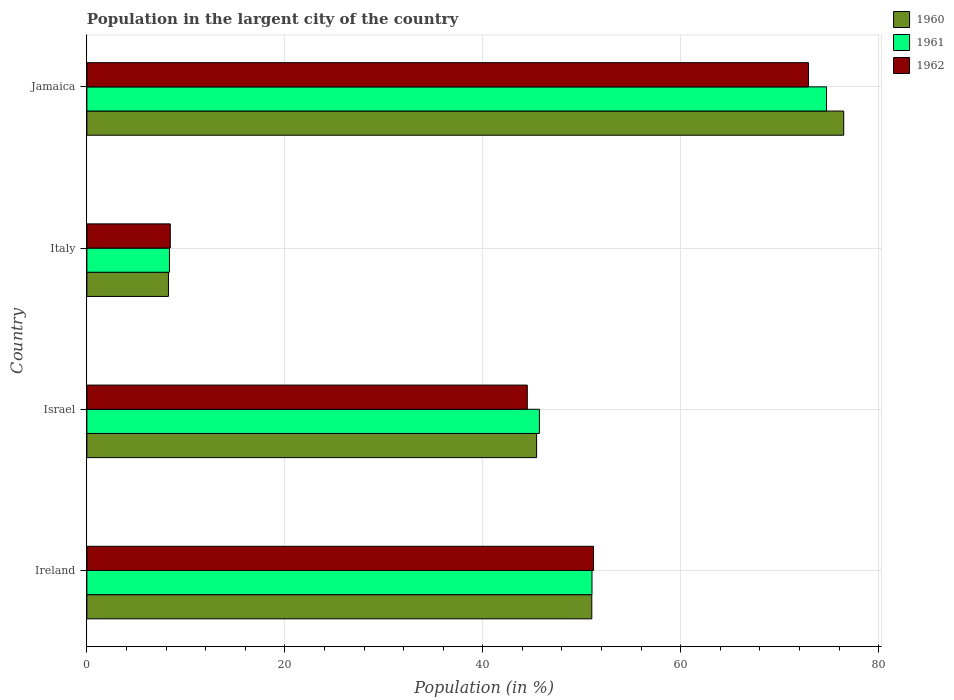Are the number of bars per tick equal to the number of legend labels?
Keep it short and to the point. Yes. Are the number of bars on each tick of the Y-axis equal?
Offer a terse response. Yes. How many bars are there on the 3rd tick from the top?
Your response must be concise. 3. What is the label of the 2nd group of bars from the top?
Provide a succinct answer. Italy. What is the percentage of population in the largent city in 1962 in Italy?
Ensure brevity in your answer.  8.42. Across all countries, what is the maximum percentage of population in the largent city in 1962?
Provide a short and direct response. 72.91. Across all countries, what is the minimum percentage of population in the largent city in 1961?
Your answer should be very brief. 8.34. In which country was the percentage of population in the largent city in 1961 maximum?
Your answer should be compact. Jamaica. In which country was the percentage of population in the largent city in 1961 minimum?
Provide a succinct answer. Italy. What is the total percentage of population in the largent city in 1962 in the graph?
Your answer should be compact. 177.01. What is the difference between the percentage of population in the largent city in 1961 in Israel and that in Jamaica?
Ensure brevity in your answer.  -29.01. What is the difference between the percentage of population in the largent city in 1961 in Ireland and the percentage of population in the largent city in 1962 in Jamaica?
Your answer should be very brief. -21.88. What is the average percentage of population in the largent city in 1960 per country?
Offer a very short reply. 45.29. What is the difference between the percentage of population in the largent city in 1960 and percentage of population in the largent city in 1961 in Ireland?
Provide a succinct answer. -0.02. What is the ratio of the percentage of population in the largent city in 1960 in Ireland to that in Italy?
Offer a very short reply. 6.19. What is the difference between the highest and the second highest percentage of population in the largent city in 1960?
Provide a short and direct response. 25.45. What is the difference between the highest and the lowest percentage of population in the largent city in 1961?
Your answer should be very brief. 66.39. Is the sum of the percentage of population in the largent city in 1960 in Ireland and Jamaica greater than the maximum percentage of population in the largent city in 1961 across all countries?
Your answer should be very brief. Yes. Is it the case that in every country, the sum of the percentage of population in the largent city in 1961 and percentage of population in the largent city in 1960 is greater than the percentage of population in the largent city in 1962?
Provide a short and direct response. Yes. How many bars are there?
Give a very brief answer. 12. Are all the bars in the graph horizontal?
Ensure brevity in your answer.  Yes. Are the values on the major ticks of X-axis written in scientific E-notation?
Keep it short and to the point. No. Where does the legend appear in the graph?
Ensure brevity in your answer.  Top right. How many legend labels are there?
Provide a succinct answer. 3. What is the title of the graph?
Ensure brevity in your answer.  Population in the largent city of the country. What is the label or title of the X-axis?
Make the answer very short. Population (in %). What is the Population (in %) in 1960 in Ireland?
Offer a very short reply. 51.01. What is the Population (in %) of 1961 in Ireland?
Your answer should be compact. 51.03. What is the Population (in %) of 1962 in Ireland?
Your response must be concise. 51.19. What is the Population (in %) of 1960 in Israel?
Offer a terse response. 45.44. What is the Population (in %) of 1961 in Israel?
Offer a very short reply. 45.72. What is the Population (in %) in 1962 in Israel?
Ensure brevity in your answer.  44.5. What is the Population (in %) of 1960 in Italy?
Make the answer very short. 8.24. What is the Population (in %) in 1961 in Italy?
Your answer should be very brief. 8.34. What is the Population (in %) in 1962 in Italy?
Provide a short and direct response. 8.42. What is the Population (in %) in 1960 in Jamaica?
Offer a terse response. 76.46. What is the Population (in %) of 1961 in Jamaica?
Provide a short and direct response. 74.73. What is the Population (in %) of 1962 in Jamaica?
Your answer should be very brief. 72.91. Across all countries, what is the maximum Population (in %) in 1960?
Your answer should be very brief. 76.46. Across all countries, what is the maximum Population (in %) of 1961?
Your answer should be very brief. 74.73. Across all countries, what is the maximum Population (in %) of 1962?
Give a very brief answer. 72.91. Across all countries, what is the minimum Population (in %) of 1960?
Give a very brief answer. 8.24. Across all countries, what is the minimum Population (in %) in 1961?
Keep it short and to the point. 8.34. Across all countries, what is the minimum Population (in %) in 1962?
Offer a very short reply. 8.42. What is the total Population (in %) in 1960 in the graph?
Offer a terse response. 181.16. What is the total Population (in %) in 1961 in the graph?
Keep it short and to the point. 179.82. What is the total Population (in %) of 1962 in the graph?
Provide a short and direct response. 177.01. What is the difference between the Population (in %) of 1960 in Ireland and that in Israel?
Offer a terse response. 5.58. What is the difference between the Population (in %) of 1961 in Ireland and that in Israel?
Give a very brief answer. 5.31. What is the difference between the Population (in %) of 1962 in Ireland and that in Israel?
Ensure brevity in your answer.  6.69. What is the difference between the Population (in %) of 1960 in Ireland and that in Italy?
Ensure brevity in your answer.  42.77. What is the difference between the Population (in %) in 1961 in Ireland and that in Italy?
Your answer should be very brief. 42.69. What is the difference between the Population (in %) in 1962 in Ireland and that in Italy?
Ensure brevity in your answer.  42.76. What is the difference between the Population (in %) of 1960 in Ireland and that in Jamaica?
Your answer should be compact. -25.45. What is the difference between the Population (in %) of 1961 in Ireland and that in Jamaica?
Your response must be concise. -23.7. What is the difference between the Population (in %) of 1962 in Ireland and that in Jamaica?
Offer a terse response. -21.72. What is the difference between the Population (in %) in 1960 in Israel and that in Italy?
Keep it short and to the point. 37.2. What is the difference between the Population (in %) of 1961 in Israel and that in Italy?
Your answer should be compact. 37.38. What is the difference between the Population (in %) of 1962 in Israel and that in Italy?
Your answer should be very brief. 36.07. What is the difference between the Population (in %) in 1960 in Israel and that in Jamaica?
Keep it short and to the point. -31.03. What is the difference between the Population (in %) of 1961 in Israel and that in Jamaica?
Provide a short and direct response. -29.01. What is the difference between the Population (in %) of 1962 in Israel and that in Jamaica?
Offer a very short reply. -28.41. What is the difference between the Population (in %) of 1960 in Italy and that in Jamaica?
Offer a very short reply. -68.22. What is the difference between the Population (in %) of 1961 in Italy and that in Jamaica?
Your response must be concise. -66.39. What is the difference between the Population (in %) of 1962 in Italy and that in Jamaica?
Give a very brief answer. -64.48. What is the difference between the Population (in %) in 1960 in Ireland and the Population (in %) in 1961 in Israel?
Offer a very short reply. 5.29. What is the difference between the Population (in %) in 1960 in Ireland and the Population (in %) in 1962 in Israel?
Provide a short and direct response. 6.52. What is the difference between the Population (in %) in 1961 in Ireland and the Population (in %) in 1962 in Israel?
Make the answer very short. 6.54. What is the difference between the Population (in %) in 1960 in Ireland and the Population (in %) in 1961 in Italy?
Provide a short and direct response. 42.67. What is the difference between the Population (in %) of 1960 in Ireland and the Population (in %) of 1962 in Italy?
Ensure brevity in your answer.  42.59. What is the difference between the Population (in %) in 1961 in Ireland and the Population (in %) in 1962 in Italy?
Provide a short and direct response. 42.61. What is the difference between the Population (in %) of 1960 in Ireland and the Population (in %) of 1961 in Jamaica?
Keep it short and to the point. -23.72. What is the difference between the Population (in %) in 1960 in Ireland and the Population (in %) in 1962 in Jamaica?
Provide a short and direct response. -21.89. What is the difference between the Population (in %) of 1961 in Ireland and the Population (in %) of 1962 in Jamaica?
Offer a very short reply. -21.88. What is the difference between the Population (in %) in 1960 in Israel and the Population (in %) in 1961 in Italy?
Ensure brevity in your answer.  37.1. What is the difference between the Population (in %) of 1960 in Israel and the Population (in %) of 1962 in Italy?
Keep it short and to the point. 37.01. What is the difference between the Population (in %) of 1961 in Israel and the Population (in %) of 1962 in Italy?
Offer a very short reply. 37.29. What is the difference between the Population (in %) in 1960 in Israel and the Population (in %) in 1961 in Jamaica?
Keep it short and to the point. -29.29. What is the difference between the Population (in %) of 1960 in Israel and the Population (in %) of 1962 in Jamaica?
Ensure brevity in your answer.  -27.47. What is the difference between the Population (in %) in 1961 in Israel and the Population (in %) in 1962 in Jamaica?
Make the answer very short. -27.19. What is the difference between the Population (in %) of 1960 in Italy and the Population (in %) of 1961 in Jamaica?
Offer a terse response. -66.49. What is the difference between the Population (in %) of 1960 in Italy and the Population (in %) of 1962 in Jamaica?
Your response must be concise. -64.67. What is the difference between the Population (in %) in 1961 in Italy and the Population (in %) in 1962 in Jamaica?
Your response must be concise. -64.57. What is the average Population (in %) of 1960 per country?
Offer a terse response. 45.29. What is the average Population (in %) of 1961 per country?
Your answer should be very brief. 44.96. What is the average Population (in %) of 1962 per country?
Make the answer very short. 44.25. What is the difference between the Population (in %) of 1960 and Population (in %) of 1961 in Ireland?
Make the answer very short. -0.02. What is the difference between the Population (in %) in 1960 and Population (in %) in 1962 in Ireland?
Keep it short and to the point. -0.17. What is the difference between the Population (in %) of 1961 and Population (in %) of 1962 in Ireland?
Ensure brevity in your answer.  -0.16. What is the difference between the Population (in %) in 1960 and Population (in %) in 1961 in Israel?
Make the answer very short. -0.28. What is the difference between the Population (in %) in 1960 and Population (in %) in 1962 in Israel?
Make the answer very short. 0.94. What is the difference between the Population (in %) of 1961 and Population (in %) of 1962 in Israel?
Give a very brief answer. 1.22. What is the difference between the Population (in %) in 1960 and Population (in %) in 1961 in Italy?
Provide a succinct answer. -0.1. What is the difference between the Population (in %) of 1960 and Population (in %) of 1962 in Italy?
Keep it short and to the point. -0.18. What is the difference between the Population (in %) in 1961 and Population (in %) in 1962 in Italy?
Give a very brief answer. -0.08. What is the difference between the Population (in %) of 1960 and Population (in %) of 1961 in Jamaica?
Provide a short and direct response. 1.74. What is the difference between the Population (in %) of 1960 and Population (in %) of 1962 in Jamaica?
Offer a terse response. 3.56. What is the difference between the Population (in %) in 1961 and Population (in %) in 1962 in Jamaica?
Your answer should be compact. 1.82. What is the ratio of the Population (in %) of 1960 in Ireland to that in Israel?
Your answer should be compact. 1.12. What is the ratio of the Population (in %) of 1961 in Ireland to that in Israel?
Your answer should be very brief. 1.12. What is the ratio of the Population (in %) in 1962 in Ireland to that in Israel?
Provide a succinct answer. 1.15. What is the ratio of the Population (in %) in 1960 in Ireland to that in Italy?
Ensure brevity in your answer.  6.19. What is the ratio of the Population (in %) in 1961 in Ireland to that in Italy?
Keep it short and to the point. 6.12. What is the ratio of the Population (in %) in 1962 in Ireland to that in Italy?
Ensure brevity in your answer.  6.08. What is the ratio of the Population (in %) of 1960 in Ireland to that in Jamaica?
Offer a terse response. 0.67. What is the ratio of the Population (in %) of 1961 in Ireland to that in Jamaica?
Your response must be concise. 0.68. What is the ratio of the Population (in %) in 1962 in Ireland to that in Jamaica?
Keep it short and to the point. 0.7. What is the ratio of the Population (in %) of 1960 in Israel to that in Italy?
Provide a succinct answer. 5.51. What is the ratio of the Population (in %) of 1961 in Israel to that in Italy?
Make the answer very short. 5.48. What is the ratio of the Population (in %) of 1962 in Israel to that in Italy?
Your answer should be very brief. 5.28. What is the ratio of the Population (in %) of 1960 in Israel to that in Jamaica?
Keep it short and to the point. 0.59. What is the ratio of the Population (in %) of 1961 in Israel to that in Jamaica?
Your answer should be very brief. 0.61. What is the ratio of the Population (in %) of 1962 in Israel to that in Jamaica?
Offer a very short reply. 0.61. What is the ratio of the Population (in %) of 1960 in Italy to that in Jamaica?
Offer a terse response. 0.11. What is the ratio of the Population (in %) of 1961 in Italy to that in Jamaica?
Your response must be concise. 0.11. What is the ratio of the Population (in %) of 1962 in Italy to that in Jamaica?
Give a very brief answer. 0.12. What is the difference between the highest and the second highest Population (in %) in 1960?
Give a very brief answer. 25.45. What is the difference between the highest and the second highest Population (in %) in 1961?
Your answer should be compact. 23.7. What is the difference between the highest and the second highest Population (in %) of 1962?
Give a very brief answer. 21.72. What is the difference between the highest and the lowest Population (in %) in 1960?
Make the answer very short. 68.22. What is the difference between the highest and the lowest Population (in %) in 1961?
Provide a succinct answer. 66.39. What is the difference between the highest and the lowest Population (in %) of 1962?
Provide a short and direct response. 64.48. 